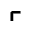<formula> <loc_0><loc_0><loc_500><loc_500>\ulcorner</formula> 